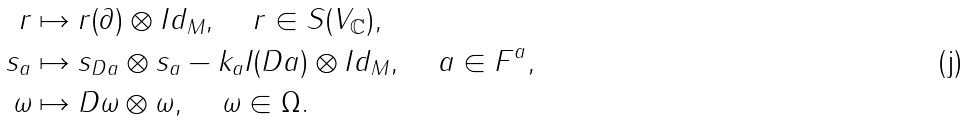Convert formula to latex. <formula><loc_0><loc_0><loc_500><loc_500>r & \mapsto r ( \partial ) \otimes I d _ { M } , \, \quad r \in S ( V _ { \mathbb { C } } ) , \\ s _ { a } & \mapsto s _ { D a } \otimes s _ { a } - k _ { a } I ( D a ) \otimes I d _ { M } , \quad \, a \in F ^ { a } , \\ \omega & \mapsto D \omega \otimes \omega , \quad \, \omega \in \Omega .</formula> 